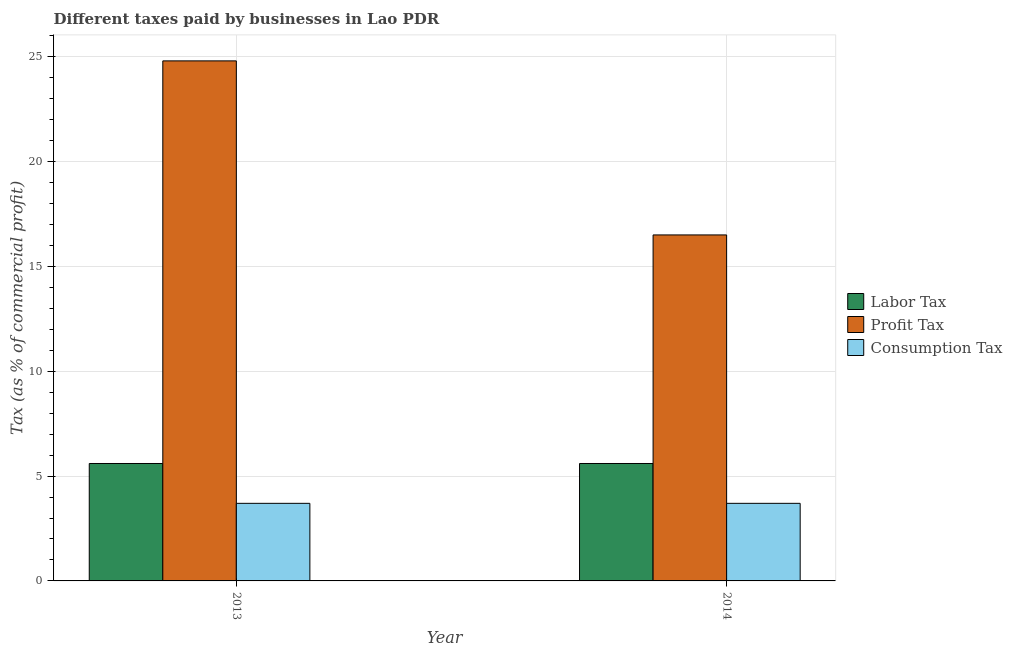How many different coloured bars are there?
Offer a terse response. 3. How many groups of bars are there?
Give a very brief answer. 2. Are the number of bars per tick equal to the number of legend labels?
Offer a terse response. Yes. Are the number of bars on each tick of the X-axis equal?
Keep it short and to the point. Yes. How many bars are there on the 1st tick from the left?
Your answer should be very brief. 3. What is the label of the 1st group of bars from the left?
Your response must be concise. 2013. In how many cases, is the number of bars for a given year not equal to the number of legend labels?
Make the answer very short. 0. What is the percentage of labor tax in 2013?
Make the answer very short. 5.6. Across all years, what is the maximum percentage of profit tax?
Keep it short and to the point. 24.8. In which year was the percentage of consumption tax minimum?
Give a very brief answer. 2013. What is the difference between the percentage of profit tax in 2013 and that in 2014?
Ensure brevity in your answer.  8.3. What is the difference between the percentage of profit tax in 2013 and the percentage of consumption tax in 2014?
Offer a terse response. 8.3. What is the average percentage of profit tax per year?
Your answer should be very brief. 20.65. In how many years, is the percentage of labor tax greater than 24 %?
Your response must be concise. 0. What is the ratio of the percentage of profit tax in 2013 to that in 2014?
Your response must be concise. 1.5. Is the percentage of consumption tax in 2013 less than that in 2014?
Offer a terse response. No. In how many years, is the percentage of profit tax greater than the average percentage of profit tax taken over all years?
Keep it short and to the point. 1. What does the 1st bar from the left in 2013 represents?
Keep it short and to the point. Labor Tax. What does the 2nd bar from the right in 2014 represents?
Make the answer very short. Profit Tax. Is it the case that in every year, the sum of the percentage of labor tax and percentage of profit tax is greater than the percentage of consumption tax?
Keep it short and to the point. Yes. How many bars are there?
Your answer should be very brief. 6. Are all the bars in the graph horizontal?
Provide a succinct answer. No. What is the difference between two consecutive major ticks on the Y-axis?
Provide a short and direct response. 5. How many legend labels are there?
Keep it short and to the point. 3. How are the legend labels stacked?
Offer a terse response. Vertical. What is the title of the graph?
Offer a very short reply. Different taxes paid by businesses in Lao PDR. What is the label or title of the X-axis?
Keep it short and to the point. Year. What is the label or title of the Y-axis?
Keep it short and to the point. Tax (as % of commercial profit). What is the Tax (as % of commercial profit) of Profit Tax in 2013?
Your response must be concise. 24.8. What is the Tax (as % of commercial profit) in Consumption Tax in 2013?
Ensure brevity in your answer.  3.7. What is the Tax (as % of commercial profit) in Labor Tax in 2014?
Offer a terse response. 5.6. What is the Tax (as % of commercial profit) in Consumption Tax in 2014?
Offer a very short reply. 3.7. Across all years, what is the maximum Tax (as % of commercial profit) in Profit Tax?
Ensure brevity in your answer.  24.8. Across all years, what is the minimum Tax (as % of commercial profit) in Labor Tax?
Provide a short and direct response. 5.6. What is the total Tax (as % of commercial profit) of Labor Tax in the graph?
Make the answer very short. 11.2. What is the total Tax (as % of commercial profit) in Profit Tax in the graph?
Offer a very short reply. 41.3. What is the total Tax (as % of commercial profit) of Consumption Tax in the graph?
Make the answer very short. 7.4. What is the difference between the Tax (as % of commercial profit) in Profit Tax in 2013 and that in 2014?
Make the answer very short. 8.3. What is the difference between the Tax (as % of commercial profit) in Labor Tax in 2013 and the Tax (as % of commercial profit) in Consumption Tax in 2014?
Make the answer very short. 1.9. What is the difference between the Tax (as % of commercial profit) of Profit Tax in 2013 and the Tax (as % of commercial profit) of Consumption Tax in 2014?
Your answer should be very brief. 21.1. What is the average Tax (as % of commercial profit) in Profit Tax per year?
Your response must be concise. 20.65. What is the average Tax (as % of commercial profit) of Consumption Tax per year?
Provide a succinct answer. 3.7. In the year 2013, what is the difference between the Tax (as % of commercial profit) of Labor Tax and Tax (as % of commercial profit) of Profit Tax?
Make the answer very short. -19.2. In the year 2013, what is the difference between the Tax (as % of commercial profit) in Labor Tax and Tax (as % of commercial profit) in Consumption Tax?
Provide a succinct answer. 1.9. In the year 2013, what is the difference between the Tax (as % of commercial profit) in Profit Tax and Tax (as % of commercial profit) in Consumption Tax?
Make the answer very short. 21.1. In the year 2014, what is the difference between the Tax (as % of commercial profit) in Profit Tax and Tax (as % of commercial profit) in Consumption Tax?
Keep it short and to the point. 12.8. What is the ratio of the Tax (as % of commercial profit) in Labor Tax in 2013 to that in 2014?
Your response must be concise. 1. What is the ratio of the Tax (as % of commercial profit) of Profit Tax in 2013 to that in 2014?
Offer a very short reply. 1.5. What is the difference between the highest and the second highest Tax (as % of commercial profit) in Labor Tax?
Keep it short and to the point. 0. What is the difference between the highest and the second highest Tax (as % of commercial profit) in Profit Tax?
Ensure brevity in your answer.  8.3. What is the difference between the highest and the second highest Tax (as % of commercial profit) in Consumption Tax?
Your response must be concise. 0. What is the difference between the highest and the lowest Tax (as % of commercial profit) of Profit Tax?
Keep it short and to the point. 8.3. 